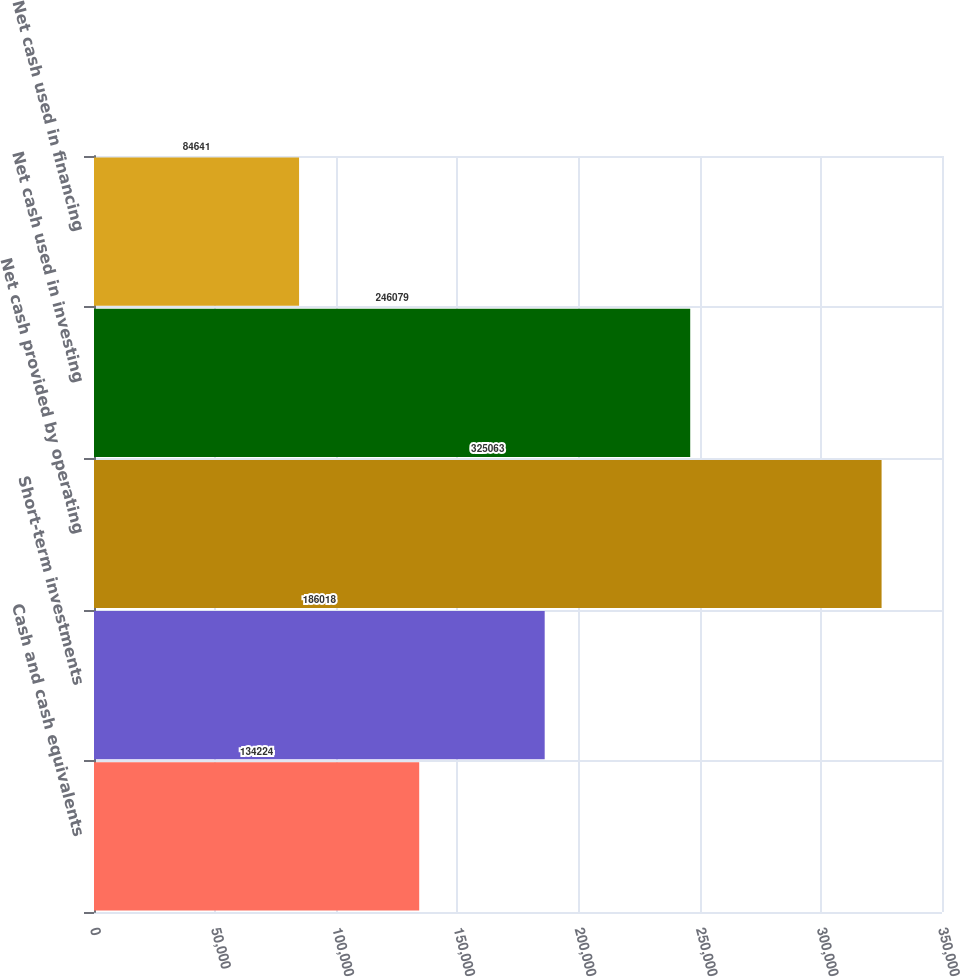Convert chart to OTSL. <chart><loc_0><loc_0><loc_500><loc_500><bar_chart><fcel>Cash and cash equivalents<fcel>Short-term investments<fcel>Net cash provided by operating<fcel>Net cash used in investing<fcel>Net cash used in financing<nl><fcel>134224<fcel>186018<fcel>325063<fcel>246079<fcel>84641<nl></chart> 